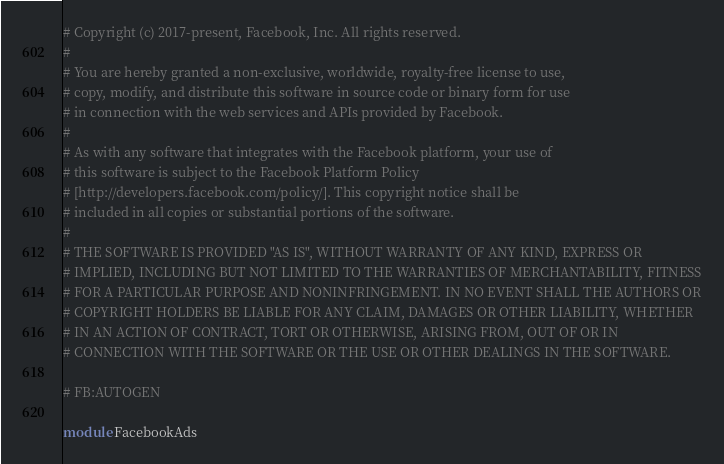<code> <loc_0><loc_0><loc_500><loc_500><_Ruby_># Copyright (c) 2017-present, Facebook, Inc. All rights reserved.
#
# You are hereby granted a non-exclusive, worldwide, royalty-free license to use,
# copy, modify, and distribute this software in source code or binary form for use
# in connection with the web services and APIs provided by Facebook.
#
# As with any software that integrates with the Facebook platform, your use of
# this software is subject to the Facebook Platform Policy
# [http://developers.facebook.com/policy/]. This copyright notice shall be
# included in all copies or substantial portions of the software.
#
# THE SOFTWARE IS PROVIDED "AS IS", WITHOUT WARRANTY OF ANY KIND, EXPRESS OR
# IMPLIED, INCLUDING BUT NOT LIMITED TO THE WARRANTIES OF MERCHANTABILITY, FITNESS
# FOR A PARTICULAR PURPOSE AND NONINFRINGEMENT. IN NO EVENT SHALL THE AUTHORS OR
# COPYRIGHT HOLDERS BE LIABLE FOR ANY CLAIM, DAMAGES OR OTHER LIABILITY, WHETHER
# IN AN ACTION OF CONTRACT, TORT OR OTHERWISE, ARISING FROM, OUT OF OR IN
# CONNECTION WITH THE SOFTWARE OR THE USE OR OTHER DEALINGS IN THE SOFTWARE.

# FB:AUTOGEN

module FacebookAds</code> 